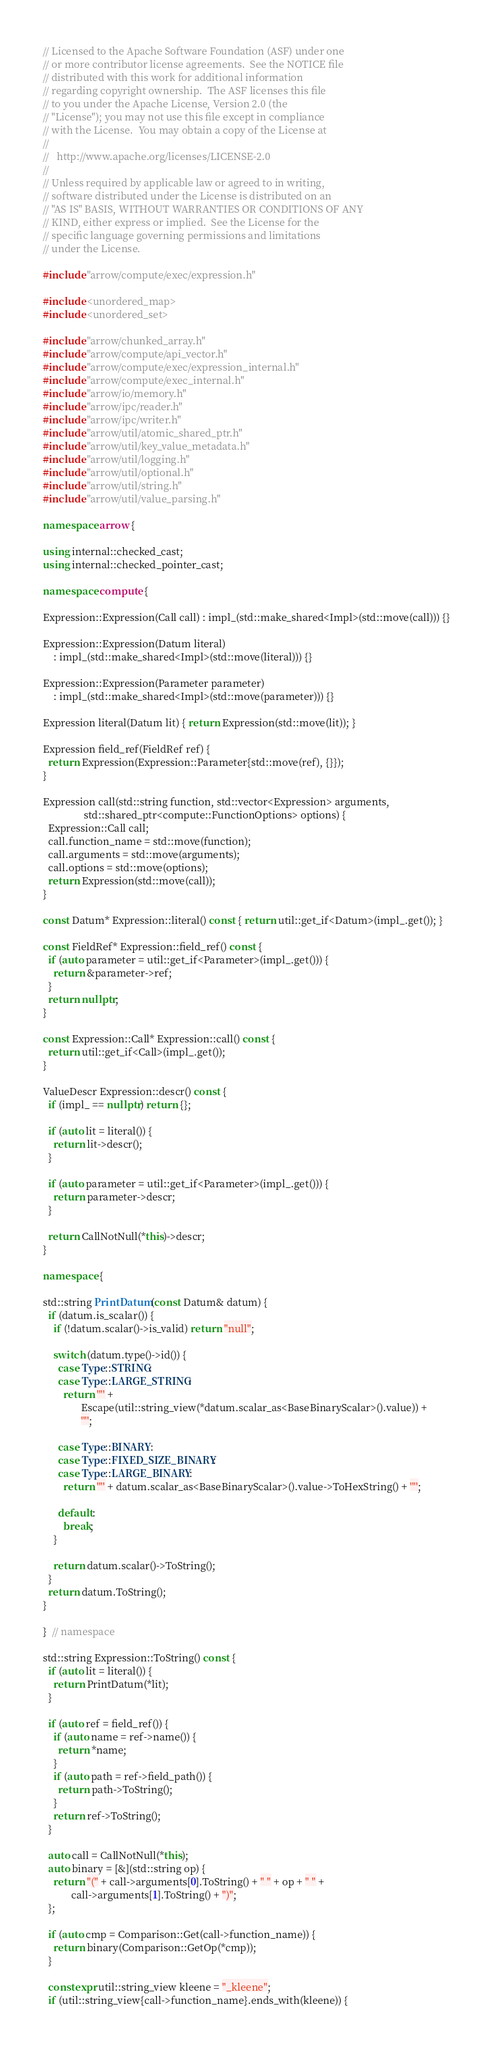Convert code to text. <code><loc_0><loc_0><loc_500><loc_500><_C++_>// Licensed to the Apache Software Foundation (ASF) under one
// or more contributor license agreements.  See the NOTICE file
// distributed with this work for additional information
// regarding copyright ownership.  The ASF licenses this file
// to you under the Apache License, Version 2.0 (the
// "License"); you may not use this file except in compliance
// with the License.  You may obtain a copy of the License at
//
//   http://www.apache.org/licenses/LICENSE-2.0
//
// Unless required by applicable law or agreed to in writing,
// software distributed under the License is distributed on an
// "AS IS" BASIS, WITHOUT WARRANTIES OR CONDITIONS OF ANY
// KIND, either express or implied.  See the License for the
// specific language governing permissions and limitations
// under the License.

#include "arrow/compute/exec/expression.h"

#include <unordered_map>
#include <unordered_set>

#include "arrow/chunked_array.h"
#include "arrow/compute/api_vector.h"
#include "arrow/compute/exec/expression_internal.h"
#include "arrow/compute/exec_internal.h"
#include "arrow/io/memory.h"
#include "arrow/ipc/reader.h"
#include "arrow/ipc/writer.h"
#include "arrow/util/atomic_shared_ptr.h"
#include "arrow/util/key_value_metadata.h"
#include "arrow/util/logging.h"
#include "arrow/util/optional.h"
#include "arrow/util/string.h"
#include "arrow/util/value_parsing.h"

namespace arrow {

using internal::checked_cast;
using internal::checked_pointer_cast;

namespace compute {

Expression::Expression(Call call) : impl_(std::make_shared<Impl>(std::move(call))) {}

Expression::Expression(Datum literal)
    : impl_(std::make_shared<Impl>(std::move(literal))) {}

Expression::Expression(Parameter parameter)
    : impl_(std::make_shared<Impl>(std::move(parameter))) {}

Expression literal(Datum lit) { return Expression(std::move(lit)); }

Expression field_ref(FieldRef ref) {
  return Expression(Expression::Parameter{std::move(ref), {}});
}

Expression call(std::string function, std::vector<Expression> arguments,
                std::shared_ptr<compute::FunctionOptions> options) {
  Expression::Call call;
  call.function_name = std::move(function);
  call.arguments = std::move(arguments);
  call.options = std::move(options);
  return Expression(std::move(call));
}

const Datum* Expression::literal() const { return util::get_if<Datum>(impl_.get()); }

const FieldRef* Expression::field_ref() const {
  if (auto parameter = util::get_if<Parameter>(impl_.get())) {
    return &parameter->ref;
  }
  return nullptr;
}

const Expression::Call* Expression::call() const {
  return util::get_if<Call>(impl_.get());
}

ValueDescr Expression::descr() const {
  if (impl_ == nullptr) return {};

  if (auto lit = literal()) {
    return lit->descr();
  }

  if (auto parameter = util::get_if<Parameter>(impl_.get())) {
    return parameter->descr;
  }

  return CallNotNull(*this)->descr;
}

namespace {

std::string PrintDatum(const Datum& datum) {
  if (datum.is_scalar()) {
    if (!datum.scalar()->is_valid) return "null";

    switch (datum.type()->id()) {
      case Type::STRING:
      case Type::LARGE_STRING:
        return '"' +
               Escape(util::string_view(*datum.scalar_as<BaseBinaryScalar>().value)) +
               '"';

      case Type::BINARY:
      case Type::FIXED_SIZE_BINARY:
      case Type::LARGE_BINARY:
        return '"' + datum.scalar_as<BaseBinaryScalar>().value->ToHexString() + '"';

      default:
        break;
    }

    return datum.scalar()->ToString();
  }
  return datum.ToString();
}

}  // namespace

std::string Expression::ToString() const {
  if (auto lit = literal()) {
    return PrintDatum(*lit);
  }

  if (auto ref = field_ref()) {
    if (auto name = ref->name()) {
      return *name;
    }
    if (auto path = ref->field_path()) {
      return path->ToString();
    }
    return ref->ToString();
  }

  auto call = CallNotNull(*this);
  auto binary = [&](std::string op) {
    return "(" + call->arguments[0].ToString() + " " + op + " " +
           call->arguments[1].ToString() + ")";
  };

  if (auto cmp = Comparison::Get(call->function_name)) {
    return binary(Comparison::GetOp(*cmp));
  }

  constexpr util::string_view kleene = "_kleene";
  if (util::string_view{call->function_name}.ends_with(kleene)) {</code> 